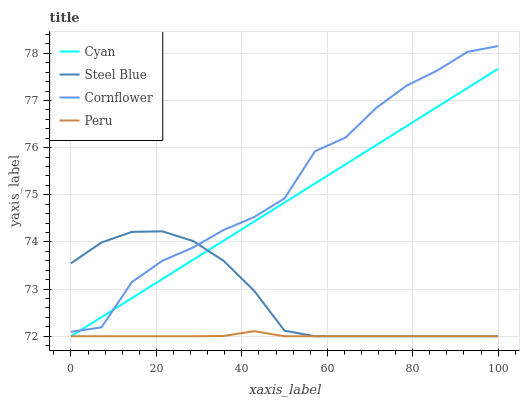Does Steel Blue have the minimum area under the curve?
Answer yes or no. No. Does Steel Blue have the maximum area under the curve?
Answer yes or no. No. Is Steel Blue the smoothest?
Answer yes or no. No. Is Steel Blue the roughest?
Answer yes or no. No. Does Cornflower have the lowest value?
Answer yes or no. No. Does Steel Blue have the highest value?
Answer yes or no. No. Is Peru less than Cornflower?
Answer yes or no. Yes. Is Cornflower greater than Peru?
Answer yes or no. Yes. Does Peru intersect Cornflower?
Answer yes or no. No. 